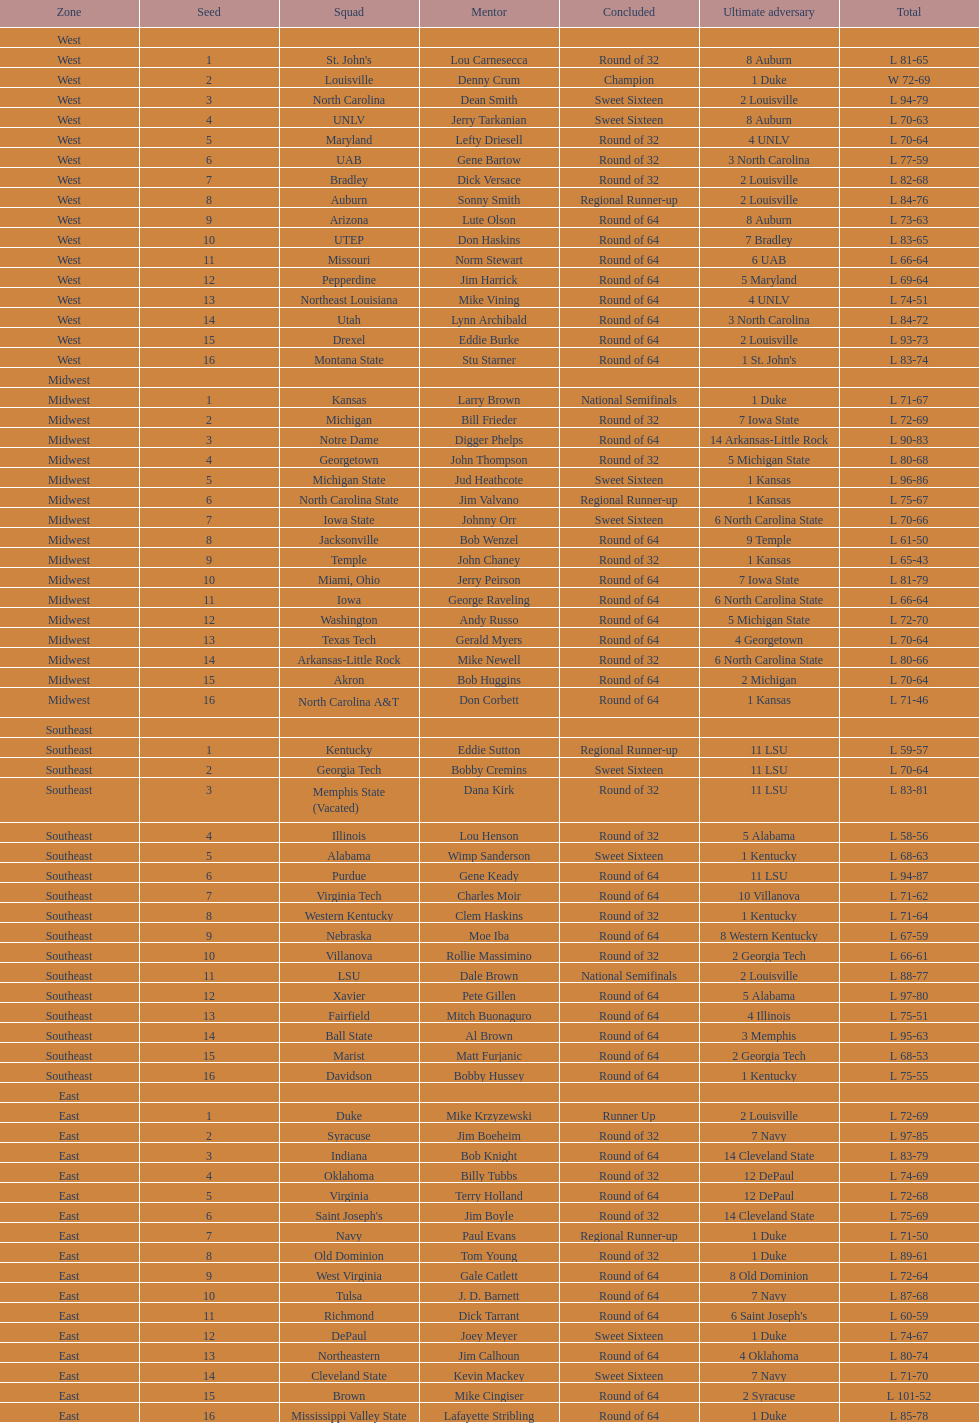Which team went finished later in the tournament, st. john's or north carolina a&t? North Carolina A&T. 